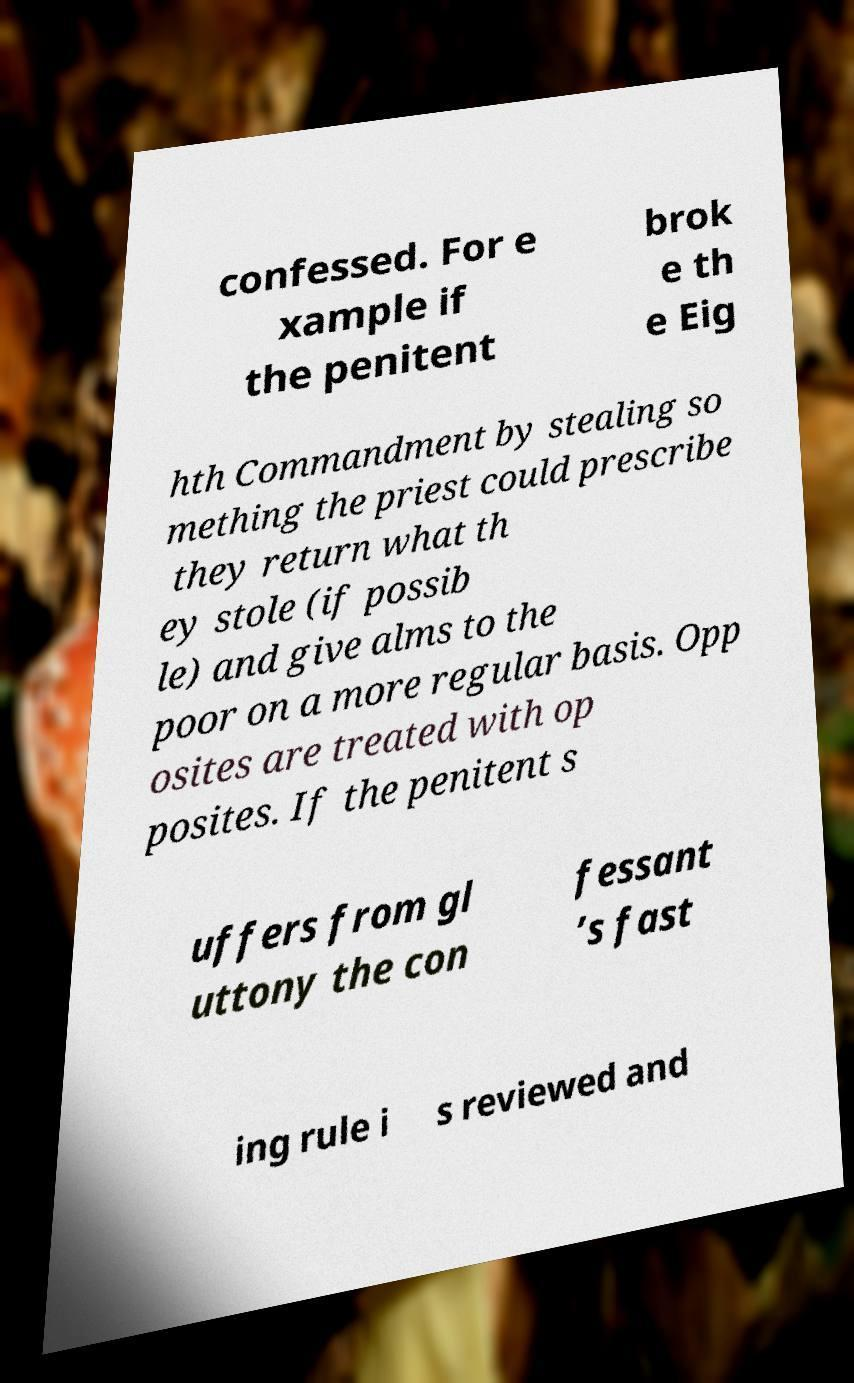Can you read and provide the text displayed in the image?This photo seems to have some interesting text. Can you extract and type it out for me? confessed. For e xample if the penitent brok e th e Eig hth Commandment by stealing so mething the priest could prescribe they return what th ey stole (if possib le) and give alms to the poor on a more regular basis. Opp osites are treated with op posites. If the penitent s uffers from gl uttony the con fessant ’s fast ing rule i s reviewed and 